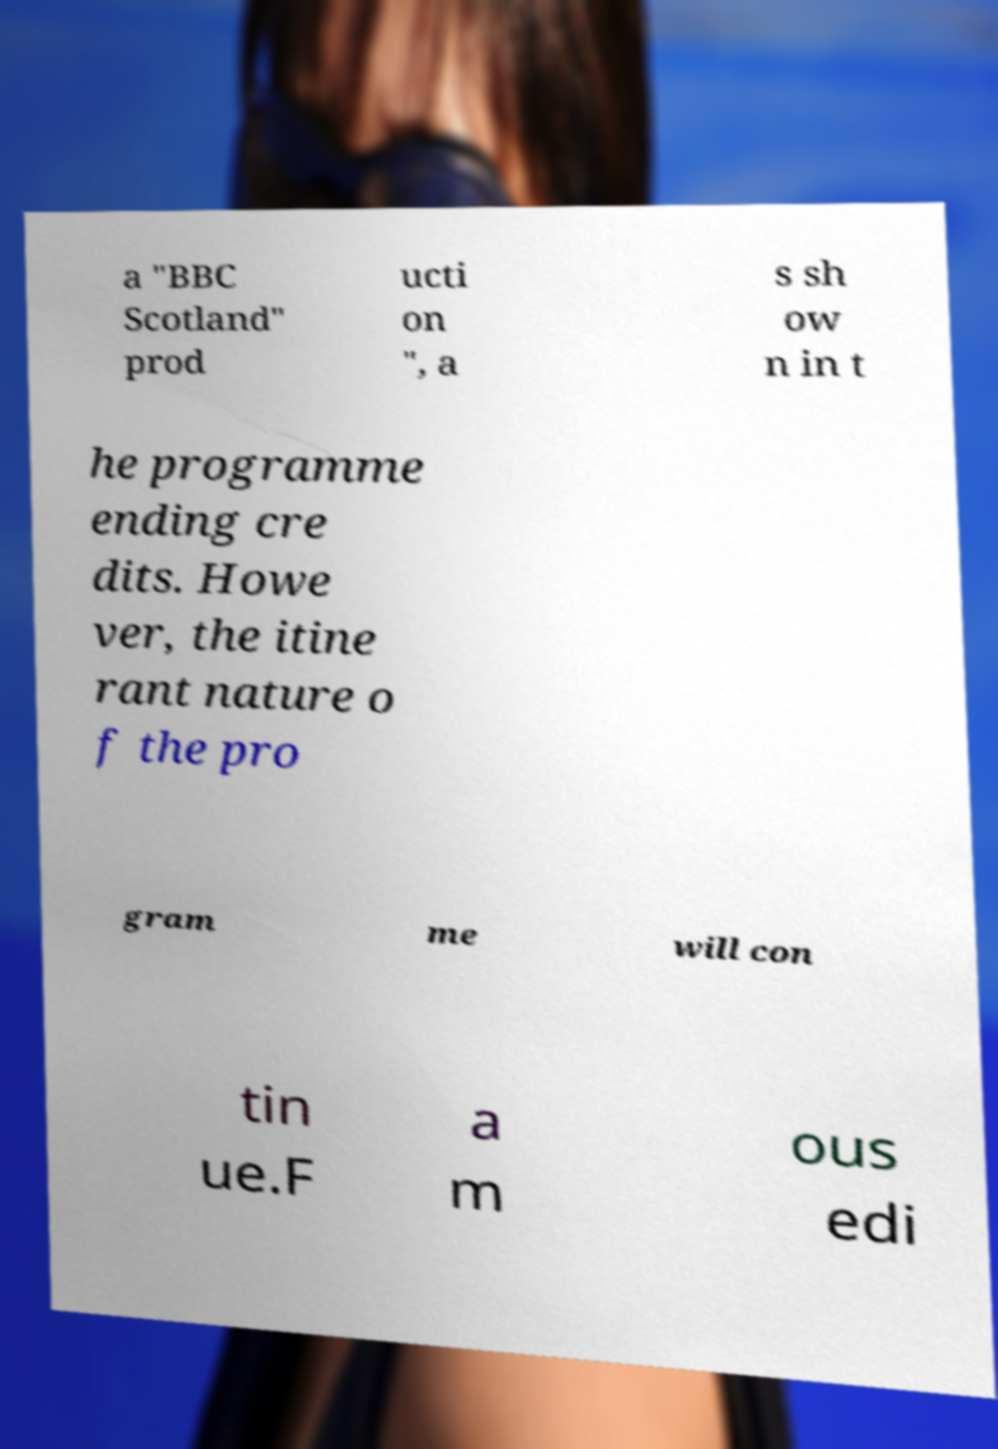Please identify and transcribe the text found in this image. a "BBC Scotland" prod ucti on ", a s sh ow n in t he programme ending cre dits. Howe ver, the itine rant nature o f the pro gram me will con tin ue.F a m ous edi 